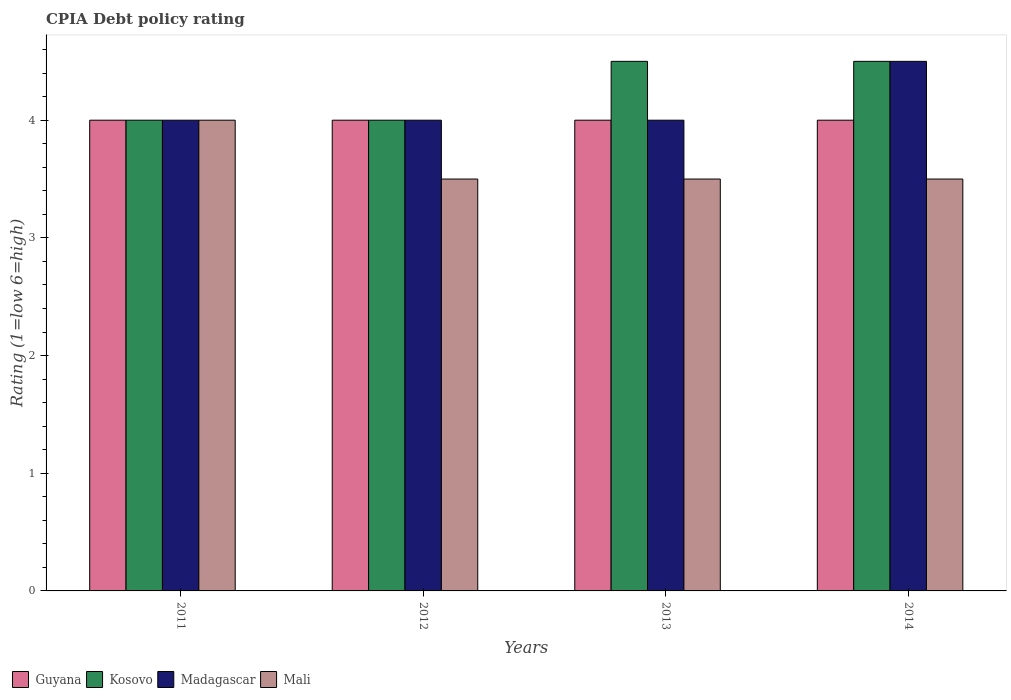How many bars are there on the 2nd tick from the right?
Your answer should be compact. 4. In how many cases, is the number of bars for a given year not equal to the number of legend labels?
Keep it short and to the point. 0. What is the CPIA rating in Mali in 2011?
Provide a short and direct response. 4. Across all years, what is the maximum CPIA rating in Kosovo?
Offer a terse response. 4.5. Across all years, what is the minimum CPIA rating in Mali?
Your response must be concise. 3.5. In which year was the CPIA rating in Madagascar minimum?
Make the answer very short. 2011. What is the total CPIA rating in Madagascar in the graph?
Provide a succinct answer. 16.5. What is the average CPIA rating in Guyana per year?
Ensure brevity in your answer.  4. What is the ratio of the CPIA rating in Kosovo in 2011 to that in 2014?
Offer a terse response. 0.89. Is the difference between the CPIA rating in Guyana in 2011 and 2013 greater than the difference between the CPIA rating in Kosovo in 2011 and 2013?
Provide a short and direct response. Yes. What is the difference between the highest and the lowest CPIA rating in Kosovo?
Offer a very short reply. 0.5. Is the sum of the CPIA rating in Mali in 2012 and 2014 greater than the maximum CPIA rating in Kosovo across all years?
Provide a short and direct response. Yes. What does the 1st bar from the left in 2012 represents?
Your answer should be compact. Guyana. What does the 2nd bar from the right in 2011 represents?
Provide a succinct answer. Madagascar. Is it the case that in every year, the sum of the CPIA rating in Guyana and CPIA rating in Kosovo is greater than the CPIA rating in Madagascar?
Your answer should be very brief. Yes. How many bars are there?
Your response must be concise. 16. How many years are there in the graph?
Your answer should be compact. 4. What is the difference between two consecutive major ticks on the Y-axis?
Offer a very short reply. 1. Are the values on the major ticks of Y-axis written in scientific E-notation?
Provide a succinct answer. No. What is the title of the graph?
Offer a very short reply. CPIA Debt policy rating. Does "Puerto Rico" appear as one of the legend labels in the graph?
Ensure brevity in your answer.  No. What is the label or title of the X-axis?
Your answer should be very brief. Years. What is the Rating (1=low 6=high) in Kosovo in 2011?
Provide a short and direct response. 4. What is the Rating (1=low 6=high) in Madagascar in 2011?
Offer a terse response. 4. What is the Rating (1=low 6=high) of Mali in 2012?
Ensure brevity in your answer.  3.5. What is the Rating (1=low 6=high) of Madagascar in 2013?
Your answer should be very brief. 4. What is the Rating (1=low 6=high) in Guyana in 2014?
Your response must be concise. 4. What is the Rating (1=low 6=high) of Kosovo in 2014?
Provide a short and direct response. 4.5. Across all years, what is the maximum Rating (1=low 6=high) in Guyana?
Offer a very short reply. 4. Across all years, what is the maximum Rating (1=low 6=high) of Madagascar?
Provide a succinct answer. 4.5. Across all years, what is the maximum Rating (1=low 6=high) in Mali?
Offer a very short reply. 4. Across all years, what is the minimum Rating (1=low 6=high) of Guyana?
Your answer should be compact. 4. What is the total Rating (1=low 6=high) of Madagascar in the graph?
Your response must be concise. 16.5. What is the total Rating (1=low 6=high) of Mali in the graph?
Your answer should be very brief. 14.5. What is the difference between the Rating (1=low 6=high) of Guyana in 2011 and that in 2013?
Give a very brief answer. 0. What is the difference between the Rating (1=low 6=high) of Kosovo in 2011 and that in 2013?
Make the answer very short. -0.5. What is the difference between the Rating (1=low 6=high) of Madagascar in 2011 and that in 2013?
Offer a very short reply. 0. What is the difference between the Rating (1=low 6=high) of Guyana in 2011 and that in 2014?
Give a very brief answer. 0. What is the difference between the Rating (1=low 6=high) in Madagascar in 2011 and that in 2014?
Keep it short and to the point. -0.5. What is the difference between the Rating (1=low 6=high) of Mali in 2011 and that in 2014?
Provide a short and direct response. 0.5. What is the difference between the Rating (1=low 6=high) of Kosovo in 2012 and that in 2013?
Your response must be concise. -0.5. What is the difference between the Rating (1=low 6=high) in Madagascar in 2012 and that in 2013?
Offer a terse response. 0. What is the difference between the Rating (1=low 6=high) of Guyana in 2012 and that in 2014?
Give a very brief answer. 0. What is the difference between the Rating (1=low 6=high) in Kosovo in 2012 and that in 2014?
Provide a short and direct response. -0.5. What is the difference between the Rating (1=low 6=high) in Mali in 2012 and that in 2014?
Provide a short and direct response. 0. What is the difference between the Rating (1=low 6=high) of Guyana in 2013 and that in 2014?
Ensure brevity in your answer.  0. What is the difference between the Rating (1=low 6=high) of Mali in 2013 and that in 2014?
Provide a succinct answer. 0. What is the difference between the Rating (1=low 6=high) of Guyana in 2011 and the Rating (1=low 6=high) of Madagascar in 2012?
Your answer should be very brief. 0. What is the difference between the Rating (1=low 6=high) of Kosovo in 2011 and the Rating (1=low 6=high) of Madagascar in 2012?
Your response must be concise. 0. What is the difference between the Rating (1=low 6=high) in Kosovo in 2011 and the Rating (1=low 6=high) in Mali in 2012?
Offer a very short reply. 0.5. What is the difference between the Rating (1=low 6=high) in Madagascar in 2011 and the Rating (1=low 6=high) in Mali in 2012?
Provide a succinct answer. 0.5. What is the difference between the Rating (1=low 6=high) in Guyana in 2011 and the Rating (1=low 6=high) in Kosovo in 2013?
Ensure brevity in your answer.  -0.5. What is the difference between the Rating (1=low 6=high) of Guyana in 2011 and the Rating (1=low 6=high) of Madagascar in 2013?
Offer a terse response. 0. What is the difference between the Rating (1=low 6=high) of Guyana in 2011 and the Rating (1=low 6=high) of Mali in 2013?
Offer a terse response. 0.5. What is the difference between the Rating (1=low 6=high) of Kosovo in 2011 and the Rating (1=low 6=high) of Madagascar in 2013?
Make the answer very short. 0. What is the difference between the Rating (1=low 6=high) of Kosovo in 2011 and the Rating (1=low 6=high) of Mali in 2013?
Provide a short and direct response. 0.5. What is the difference between the Rating (1=low 6=high) in Guyana in 2011 and the Rating (1=low 6=high) in Kosovo in 2014?
Provide a succinct answer. -0.5. What is the difference between the Rating (1=low 6=high) in Kosovo in 2011 and the Rating (1=low 6=high) in Madagascar in 2014?
Your answer should be compact. -0.5. What is the difference between the Rating (1=low 6=high) of Kosovo in 2011 and the Rating (1=low 6=high) of Mali in 2014?
Your answer should be compact. 0.5. What is the difference between the Rating (1=low 6=high) of Madagascar in 2011 and the Rating (1=low 6=high) of Mali in 2014?
Keep it short and to the point. 0.5. What is the difference between the Rating (1=low 6=high) of Guyana in 2012 and the Rating (1=low 6=high) of Mali in 2013?
Make the answer very short. 0.5. What is the difference between the Rating (1=low 6=high) of Kosovo in 2012 and the Rating (1=low 6=high) of Madagascar in 2013?
Make the answer very short. 0. What is the difference between the Rating (1=low 6=high) in Guyana in 2012 and the Rating (1=low 6=high) in Mali in 2014?
Give a very brief answer. 0.5. What is the difference between the Rating (1=low 6=high) in Madagascar in 2012 and the Rating (1=low 6=high) in Mali in 2014?
Offer a terse response. 0.5. What is the difference between the Rating (1=low 6=high) of Guyana in 2013 and the Rating (1=low 6=high) of Kosovo in 2014?
Offer a terse response. -0.5. What is the difference between the Rating (1=low 6=high) in Guyana in 2013 and the Rating (1=low 6=high) in Madagascar in 2014?
Offer a very short reply. -0.5. What is the difference between the Rating (1=low 6=high) in Kosovo in 2013 and the Rating (1=low 6=high) in Madagascar in 2014?
Offer a very short reply. 0. What is the average Rating (1=low 6=high) in Kosovo per year?
Your answer should be compact. 4.25. What is the average Rating (1=low 6=high) of Madagascar per year?
Make the answer very short. 4.12. What is the average Rating (1=low 6=high) in Mali per year?
Make the answer very short. 3.62. In the year 2011, what is the difference between the Rating (1=low 6=high) in Guyana and Rating (1=low 6=high) in Kosovo?
Your answer should be very brief. 0. In the year 2011, what is the difference between the Rating (1=low 6=high) of Guyana and Rating (1=low 6=high) of Madagascar?
Your response must be concise. 0. In the year 2011, what is the difference between the Rating (1=low 6=high) of Guyana and Rating (1=low 6=high) of Mali?
Your response must be concise. 0. In the year 2011, what is the difference between the Rating (1=low 6=high) of Kosovo and Rating (1=low 6=high) of Madagascar?
Your response must be concise. 0. In the year 2011, what is the difference between the Rating (1=low 6=high) of Kosovo and Rating (1=low 6=high) of Mali?
Your answer should be compact. 0. In the year 2011, what is the difference between the Rating (1=low 6=high) of Madagascar and Rating (1=low 6=high) of Mali?
Provide a short and direct response. 0. In the year 2012, what is the difference between the Rating (1=low 6=high) in Guyana and Rating (1=low 6=high) in Kosovo?
Your answer should be compact. 0. In the year 2012, what is the difference between the Rating (1=low 6=high) in Guyana and Rating (1=low 6=high) in Madagascar?
Offer a terse response. 0. In the year 2012, what is the difference between the Rating (1=low 6=high) of Kosovo and Rating (1=low 6=high) of Madagascar?
Ensure brevity in your answer.  0. In the year 2012, what is the difference between the Rating (1=low 6=high) of Madagascar and Rating (1=low 6=high) of Mali?
Your answer should be very brief. 0.5. In the year 2013, what is the difference between the Rating (1=low 6=high) in Guyana and Rating (1=low 6=high) in Kosovo?
Ensure brevity in your answer.  -0.5. In the year 2013, what is the difference between the Rating (1=low 6=high) in Guyana and Rating (1=low 6=high) in Mali?
Your answer should be compact. 0.5. In the year 2013, what is the difference between the Rating (1=low 6=high) of Kosovo and Rating (1=low 6=high) of Madagascar?
Your answer should be very brief. 0.5. In the year 2013, what is the difference between the Rating (1=low 6=high) in Madagascar and Rating (1=low 6=high) in Mali?
Your answer should be very brief. 0.5. In the year 2014, what is the difference between the Rating (1=low 6=high) in Guyana and Rating (1=low 6=high) in Madagascar?
Provide a succinct answer. -0.5. In the year 2014, what is the difference between the Rating (1=low 6=high) in Guyana and Rating (1=low 6=high) in Mali?
Offer a very short reply. 0.5. In the year 2014, what is the difference between the Rating (1=low 6=high) in Kosovo and Rating (1=low 6=high) in Madagascar?
Your answer should be very brief. 0. In the year 2014, what is the difference between the Rating (1=low 6=high) in Kosovo and Rating (1=low 6=high) in Mali?
Offer a terse response. 1. In the year 2014, what is the difference between the Rating (1=low 6=high) of Madagascar and Rating (1=low 6=high) of Mali?
Make the answer very short. 1. What is the ratio of the Rating (1=low 6=high) of Guyana in 2011 to that in 2012?
Provide a succinct answer. 1. What is the ratio of the Rating (1=low 6=high) in Kosovo in 2011 to that in 2012?
Your answer should be very brief. 1. What is the ratio of the Rating (1=low 6=high) of Guyana in 2011 to that in 2013?
Provide a short and direct response. 1. What is the ratio of the Rating (1=low 6=high) of Kosovo in 2011 to that in 2014?
Offer a terse response. 0.89. What is the ratio of the Rating (1=low 6=high) in Madagascar in 2011 to that in 2014?
Your answer should be very brief. 0.89. What is the ratio of the Rating (1=low 6=high) in Mali in 2012 to that in 2013?
Your response must be concise. 1. What is the ratio of the Rating (1=low 6=high) in Guyana in 2012 to that in 2014?
Offer a terse response. 1. What is the ratio of the Rating (1=low 6=high) of Kosovo in 2012 to that in 2014?
Keep it short and to the point. 0.89. What is the ratio of the Rating (1=low 6=high) in Mali in 2012 to that in 2014?
Your answer should be very brief. 1. What is the ratio of the Rating (1=low 6=high) in Guyana in 2013 to that in 2014?
Provide a succinct answer. 1. What is the difference between the highest and the second highest Rating (1=low 6=high) in Mali?
Your response must be concise. 0.5. What is the difference between the highest and the lowest Rating (1=low 6=high) in Guyana?
Keep it short and to the point. 0. 